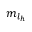<formula> <loc_0><loc_0><loc_500><loc_500>{ m } _ { l _ { h } }</formula> 